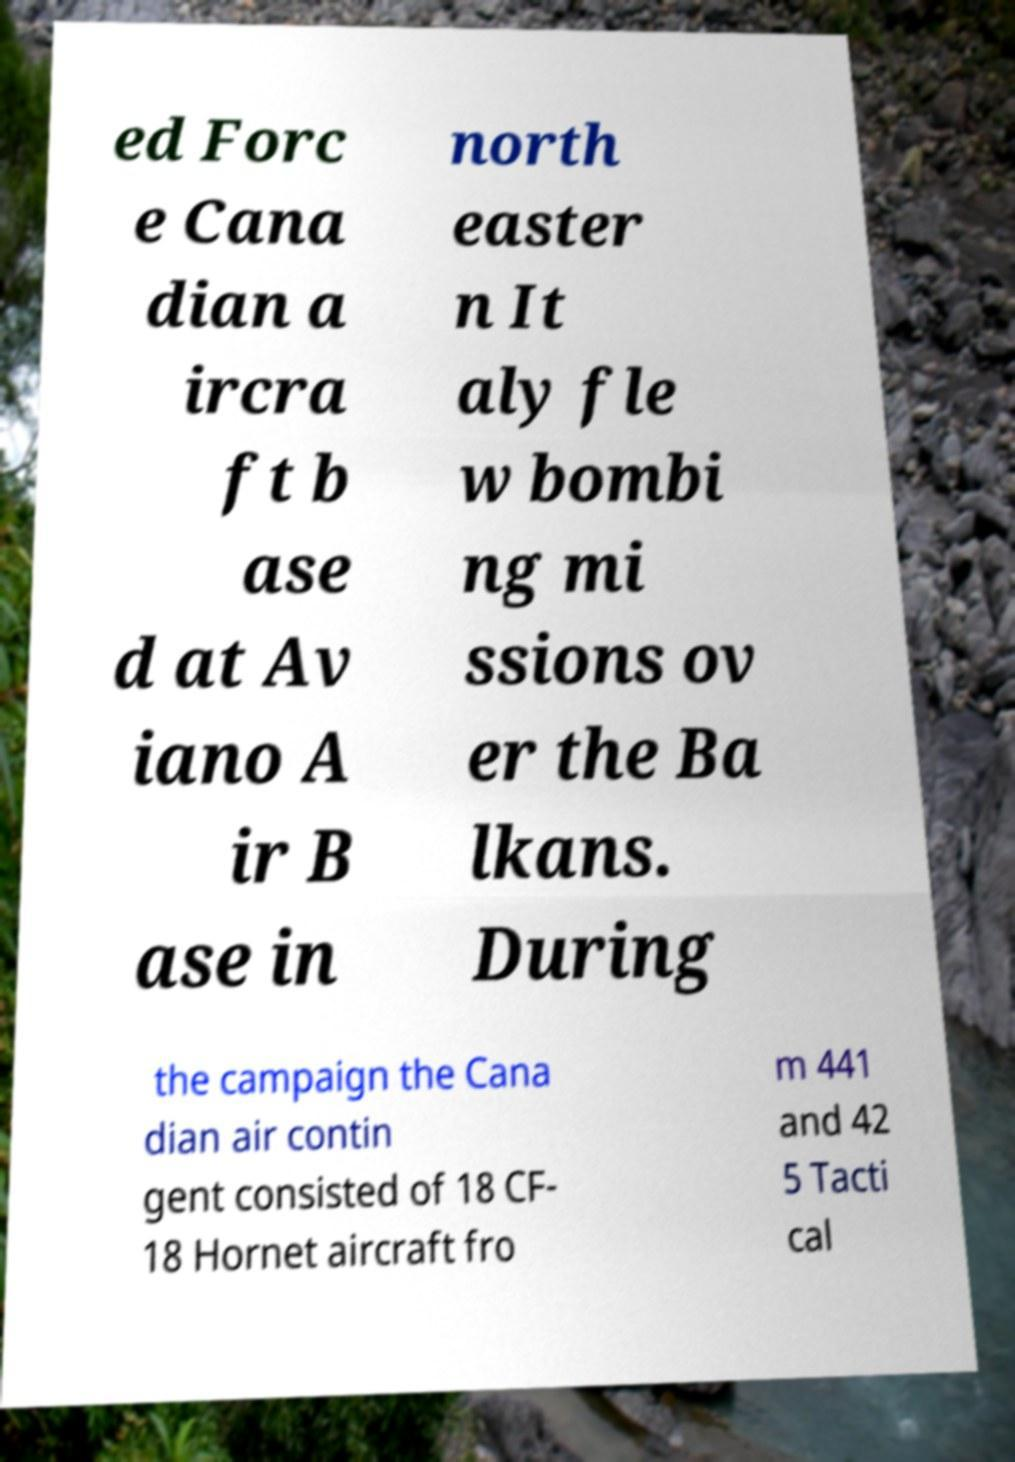Could you extract and type out the text from this image? ed Forc e Cana dian a ircra ft b ase d at Av iano A ir B ase in north easter n It aly fle w bombi ng mi ssions ov er the Ba lkans. During the campaign the Cana dian air contin gent consisted of 18 CF- 18 Hornet aircraft fro m 441 and 42 5 Tacti cal 